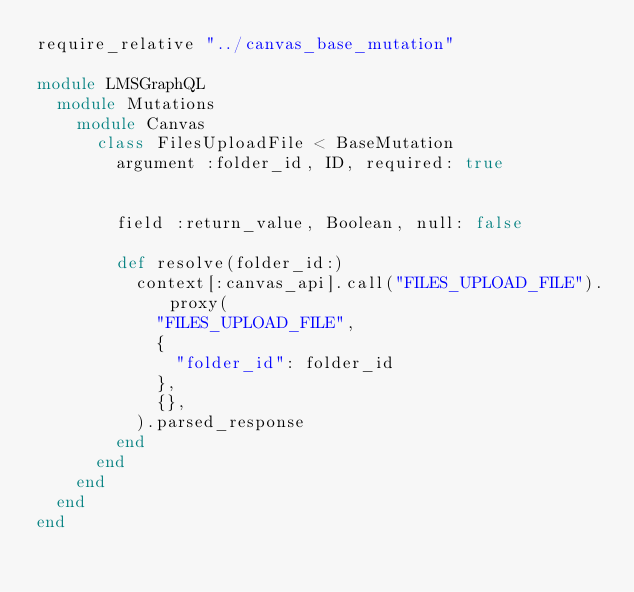Convert code to text. <code><loc_0><loc_0><loc_500><loc_500><_Ruby_>require_relative "../canvas_base_mutation"

module LMSGraphQL
  module Mutations
    module Canvas
      class FilesUploadFile < BaseMutation
        argument :folder_id, ID, required: true
        
        
        field :return_value, Boolean, null: false
        
        def resolve(folder_id:)
          context[:canvas_api].call("FILES_UPLOAD_FILE").proxy(
            "FILES_UPLOAD_FILE",
            {
              "folder_id": folder_id
            },
            {},
          ).parsed_response
        end
      end
    end
  end
end</code> 